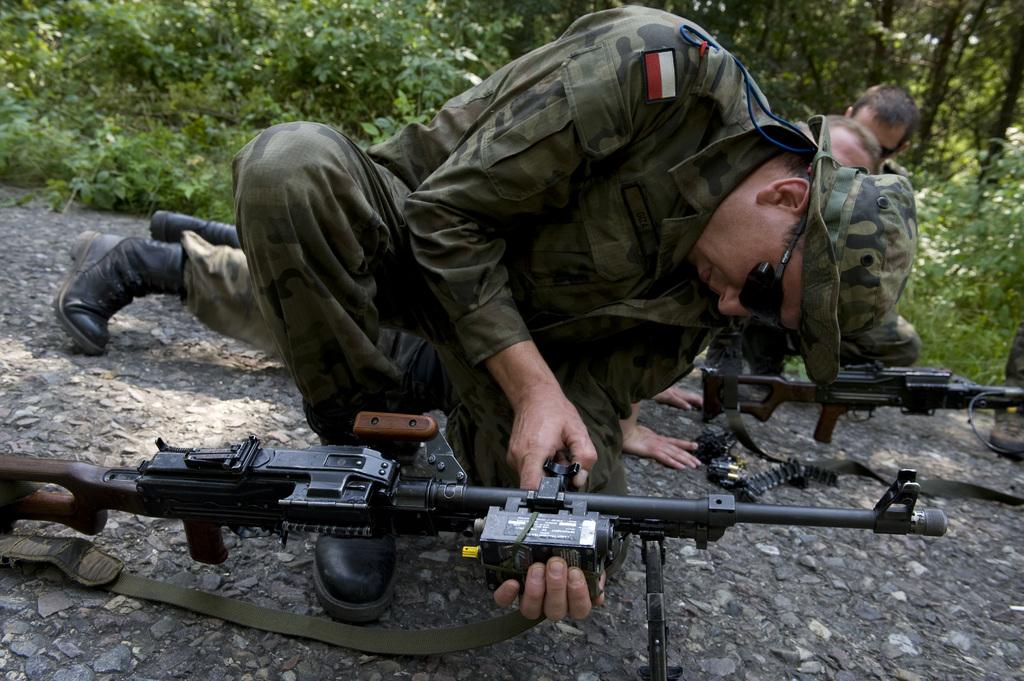What is located in the center of the image? There are people and weapons in the center of the image. What can be seen in the background of the image? There are trees and plants in the background of the image. What type of surface is at the bottom of the image? There is a stone surface at the bottom of the image. Where is the toothpaste located in the image? There is no toothpaste present in the image. What event is taking place in the image that led to the birth of a new group? There is no event related to the birth of a new group depicted in the image. 